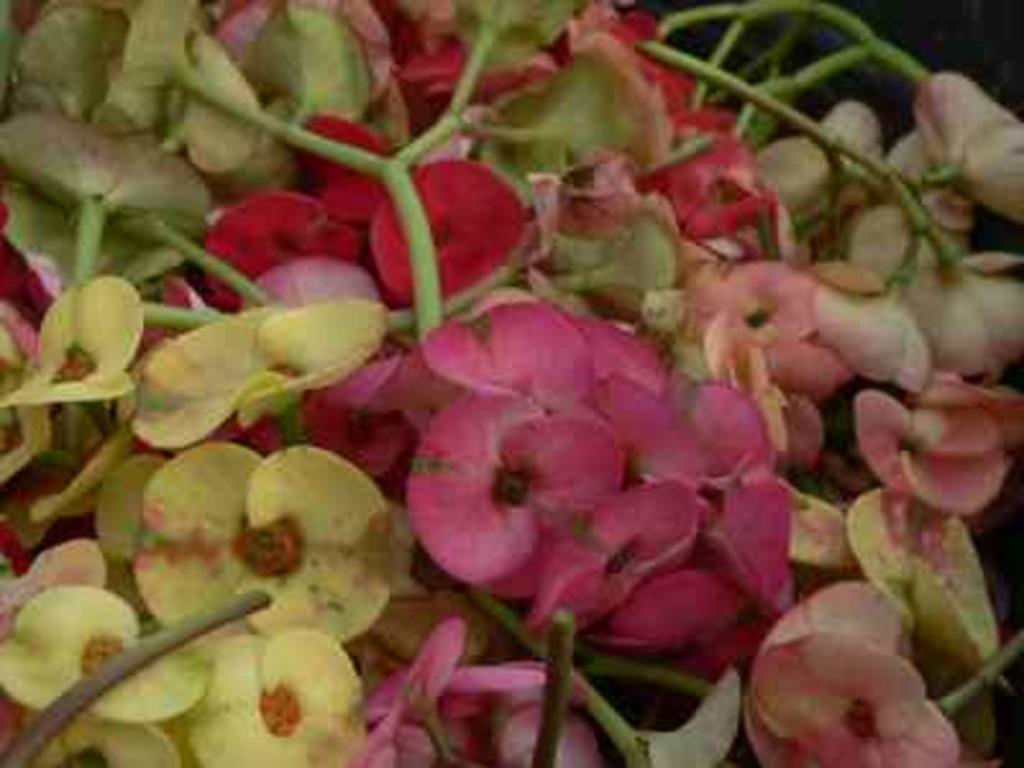What type of plant can be seen in the image? There is a tree in the image. What is the color of the tree? The tree is green in color. Are there any other plants or flowers near the tree? Yes, there are flowers near the tree. What colors can be seen on the flowers? The flowers have red, green, and white colors. Are there any other colors present on the flowers? Yes, there are also pink flowers present. What type of oatmeal is being prepared in the image? There is no oatmeal present in the image; it features a tree and flowers. What type of flame can be seen near the tree? There is no flame present near the tree in the image. 